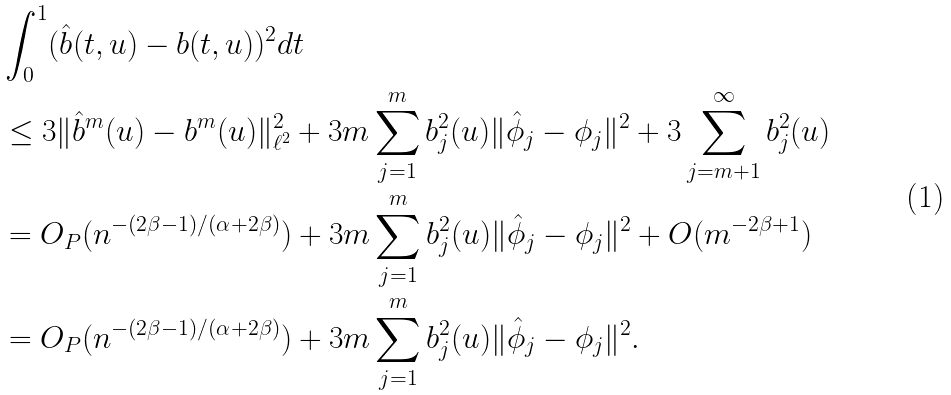<formula> <loc_0><loc_0><loc_500><loc_500>& \int _ { 0 } ^ { 1 } ( \hat { b } ( t , u ) - b ( t , u ) ) ^ { 2 } d t \\ & \leq 3 \| \hat { b } ^ { m } ( u ) - b ^ { m } ( u ) \| _ { \ell ^ { 2 } } ^ { 2 } + 3 m \sum _ { j = 1 } ^ { m } b _ { j } ^ { 2 } ( u ) \| \hat { \phi } _ { j } - \phi _ { j } \| ^ { 2 } + 3 \sum _ { j = m + 1 } ^ { \infty } b _ { j } ^ { 2 } ( u ) \\ & = O _ { P } ( n ^ { - ( 2 \beta - 1 ) / ( \alpha + 2 \beta ) } ) + 3 m \sum _ { j = 1 } ^ { m } b _ { j } ^ { 2 } ( u ) \| \hat { \phi } _ { j } - \phi _ { j } \| ^ { 2 } + O ( m ^ { - 2 \beta + 1 } ) \\ & = O _ { P } ( n ^ { - ( 2 \beta - 1 ) / ( \alpha + 2 \beta ) } ) + 3 m \sum _ { j = 1 } ^ { m } b _ { j } ^ { 2 } ( u ) \| \hat { \phi } _ { j } - \phi _ { j } \| ^ { 2 } .</formula> 